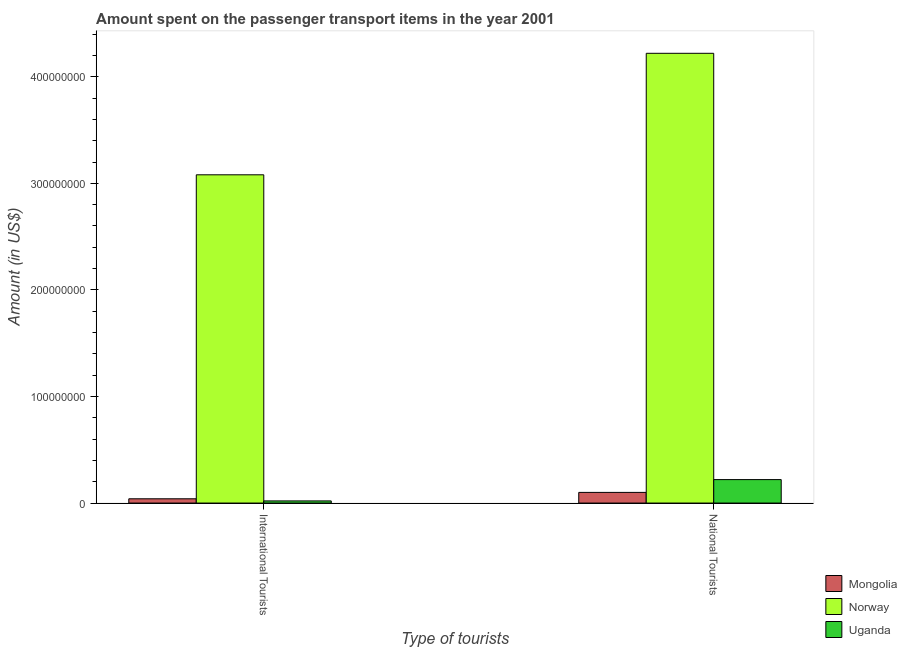How many different coloured bars are there?
Provide a succinct answer. 3. How many groups of bars are there?
Make the answer very short. 2. Are the number of bars per tick equal to the number of legend labels?
Offer a very short reply. Yes. How many bars are there on the 1st tick from the right?
Offer a very short reply. 3. What is the label of the 1st group of bars from the left?
Your answer should be very brief. International Tourists. What is the amount spent on transport items of national tourists in Norway?
Your response must be concise. 4.22e+08. Across all countries, what is the maximum amount spent on transport items of national tourists?
Your response must be concise. 4.22e+08. Across all countries, what is the minimum amount spent on transport items of international tourists?
Keep it short and to the point. 2.00e+06. In which country was the amount spent on transport items of national tourists minimum?
Ensure brevity in your answer.  Mongolia. What is the total amount spent on transport items of international tourists in the graph?
Ensure brevity in your answer.  3.14e+08. What is the difference between the amount spent on transport items of international tourists in Mongolia and that in Norway?
Ensure brevity in your answer.  -3.04e+08. What is the difference between the amount spent on transport items of international tourists in Uganda and the amount spent on transport items of national tourists in Norway?
Keep it short and to the point. -4.20e+08. What is the average amount spent on transport items of national tourists per country?
Ensure brevity in your answer.  1.51e+08. What is the difference between the amount spent on transport items of international tourists and amount spent on transport items of national tourists in Mongolia?
Provide a short and direct response. -6.00e+06. What is the ratio of the amount spent on transport items of national tourists in Norway to that in Mongolia?
Your answer should be very brief. 42.2. In how many countries, is the amount spent on transport items of national tourists greater than the average amount spent on transport items of national tourists taken over all countries?
Offer a very short reply. 1. What does the 1st bar from the left in International Tourists represents?
Offer a terse response. Mongolia. Are the values on the major ticks of Y-axis written in scientific E-notation?
Offer a terse response. No. Where does the legend appear in the graph?
Provide a short and direct response. Bottom right. How are the legend labels stacked?
Keep it short and to the point. Vertical. What is the title of the graph?
Make the answer very short. Amount spent on the passenger transport items in the year 2001. Does "Panama" appear as one of the legend labels in the graph?
Offer a very short reply. No. What is the label or title of the X-axis?
Make the answer very short. Type of tourists. What is the Amount (in US$) in Mongolia in International Tourists?
Keep it short and to the point. 4.00e+06. What is the Amount (in US$) in Norway in International Tourists?
Your answer should be very brief. 3.08e+08. What is the Amount (in US$) in Mongolia in National Tourists?
Make the answer very short. 1.00e+07. What is the Amount (in US$) in Norway in National Tourists?
Make the answer very short. 4.22e+08. What is the Amount (in US$) in Uganda in National Tourists?
Provide a short and direct response. 2.20e+07. Across all Type of tourists, what is the maximum Amount (in US$) of Mongolia?
Your answer should be very brief. 1.00e+07. Across all Type of tourists, what is the maximum Amount (in US$) of Norway?
Provide a succinct answer. 4.22e+08. Across all Type of tourists, what is the maximum Amount (in US$) in Uganda?
Your answer should be very brief. 2.20e+07. Across all Type of tourists, what is the minimum Amount (in US$) in Mongolia?
Keep it short and to the point. 4.00e+06. Across all Type of tourists, what is the minimum Amount (in US$) of Norway?
Your answer should be compact. 3.08e+08. Across all Type of tourists, what is the minimum Amount (in US$) in Uganda?
Give a very brief answer. 2.00e+06. What is the total Amount (in US$) in Mongolia in the graph?
Give a very brief answer. 1.40e+07. What is the total Amount (in US$) in Norway in the graph?
Provide a short and direct response. 7.30e+08. What is the total Amount (in US$) of Uganda in the graph?
Your answer should be compact. 2.40e+07. What is the difference between the Amount (in US$) in Mongolia in International Tourists and that in National Tourists?
Provide a succinct answer. -6.00e+06. What is the difference between the Amount (in US$) in Norway in International Tourists and that in National Tourists?
Provide a short and direct response. -1.14e+08. What is the difference between the Amount (in US$) of Uganda in International Tourists and that in National Tourists?
Give a very brief answer. -2.00e+07. What is the difference between the Amount (in US$) in Mongolia in International Tourists and the Amount (in US$) in Norway in National Tourists?
Make the answer very short. -4.18e+08. What is the difference between the Amount (in US$) in Mongolia in International Tourists and the Amount (in US$) in Uganda in National Tourists?
Provide a short and direct response. -1.80e+07. What is the difference between the Amount (in US$) in Norway in International Tourists and the Amount (in US$) in Uganda in National Tourists?
Offer a terse response. 2.86e+08. What is the average Amount (in US$) of Norway per Type of tourists?
Provide a short and direct response. 3.65e+08. What is the difference between the Amount (in US$) in Mongolia and Amount (in US$) in Norway in International Tourists?
Provide a succinct answer. -3.04e+08. What is the difference between the Amount (in US$) in Mongolia and Amount (in US$) in Uganda in International Tourists?
Your answer should be compact. 2.00e+06. What is the difference between the Amount (in US$) of Norway and Amount (in US$) of Uganda in International Tourists?
Make the answer very short. 3.06e+08. What is the difference between the Amount (in US$) in Mongolia and Amount (in US$) in Norway in National Tourists?
Offer a very short reply. -4.12e+08. What is the difference between the Amount (in US$) in Mongolia and Amount (in US$) in Uganda in National Tourists?
Give a very brief answer. -1.20e+07. What is the difference between the Amount (in US$) in Norway and Amount (in US$) in Uganda in National Tourists?
Keep it short and to the point. 4.00e+08. What is the ratio of the Amount (in US$) of Mongolia in International Tourists to that in National Tourists?
Offer a very short reply. 0.4. What is the ratio of the Amount (in US$) in Norway in International Tourists to that in National Tourists?
Give a very brief answer. 0.73. What is the ratio of the Amount (in US$) of Uganda in International Tourists to that in National Tourists?
Provide a succinct answer. 0.09. What is the difference between the highest and the second highest Amount (in US$) in Mongolia?
Your answer should be compact. 6.00e+06. What is the difference between the highest and the second highest Amount (in US$) in Norway?
Ensure brevity in your answer.  1.14e+08. What is the difference between the highest and the second highest Amount (in US$) of Uganda?
Your answer should be very brief. 2.00e+07. What is the difference between the highest and the lowest Amount (in US$) in Norway?
Keep it short and to the point. 1.14e+08. 